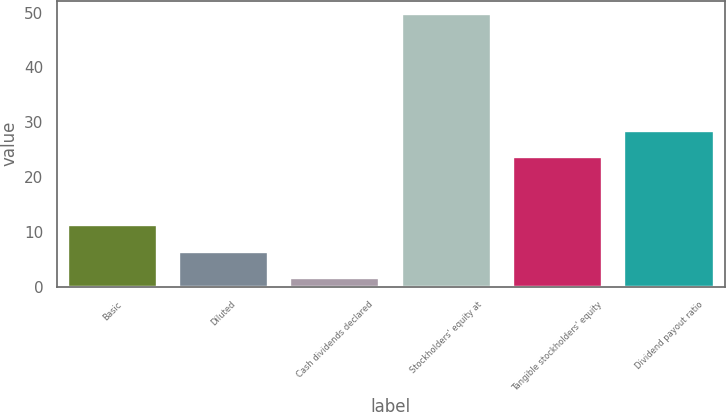Convert chart. <chart><loc_0><loc_0><loc_500><loc_500><bar_chart><fcel>Basic<fcel>Diluted<fcel>Cash dividends declared<fcel>Stockholders' equity at<fcel>Tangible stockholders' equity<fcel>Dividend payout ratio<nl><fcel>11.22<fcel>6.41<fcel>1.6<fcel>49.68<fcel>23.62<fcel>28.43<nl></chart> 